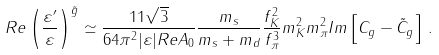<formula> <loc_0><loc_0><loc_500><loc_500>R e \left ( \frac { \varepsilon ^ { \prime } } { \varepsilon } \right ) ^ { \tilde { g } } \simeq \frac { 1 1 \sqrt { 3 } } { 6 4 \pi ^ { 2 } | \varepsilon | R e A _ { 0 } } \frac { m _ { s } } { m _ { s } + m _ { d } } \frac { f _ { K } ^ { 2 } } { f _ { \pi } ^ { 3 } } m _ { K } ^ { 2 } m _ { \pi } ^ { 2 } I m \left [ C _ { g } - \tilde { C } _ { g } \right ] \, .</formula> 